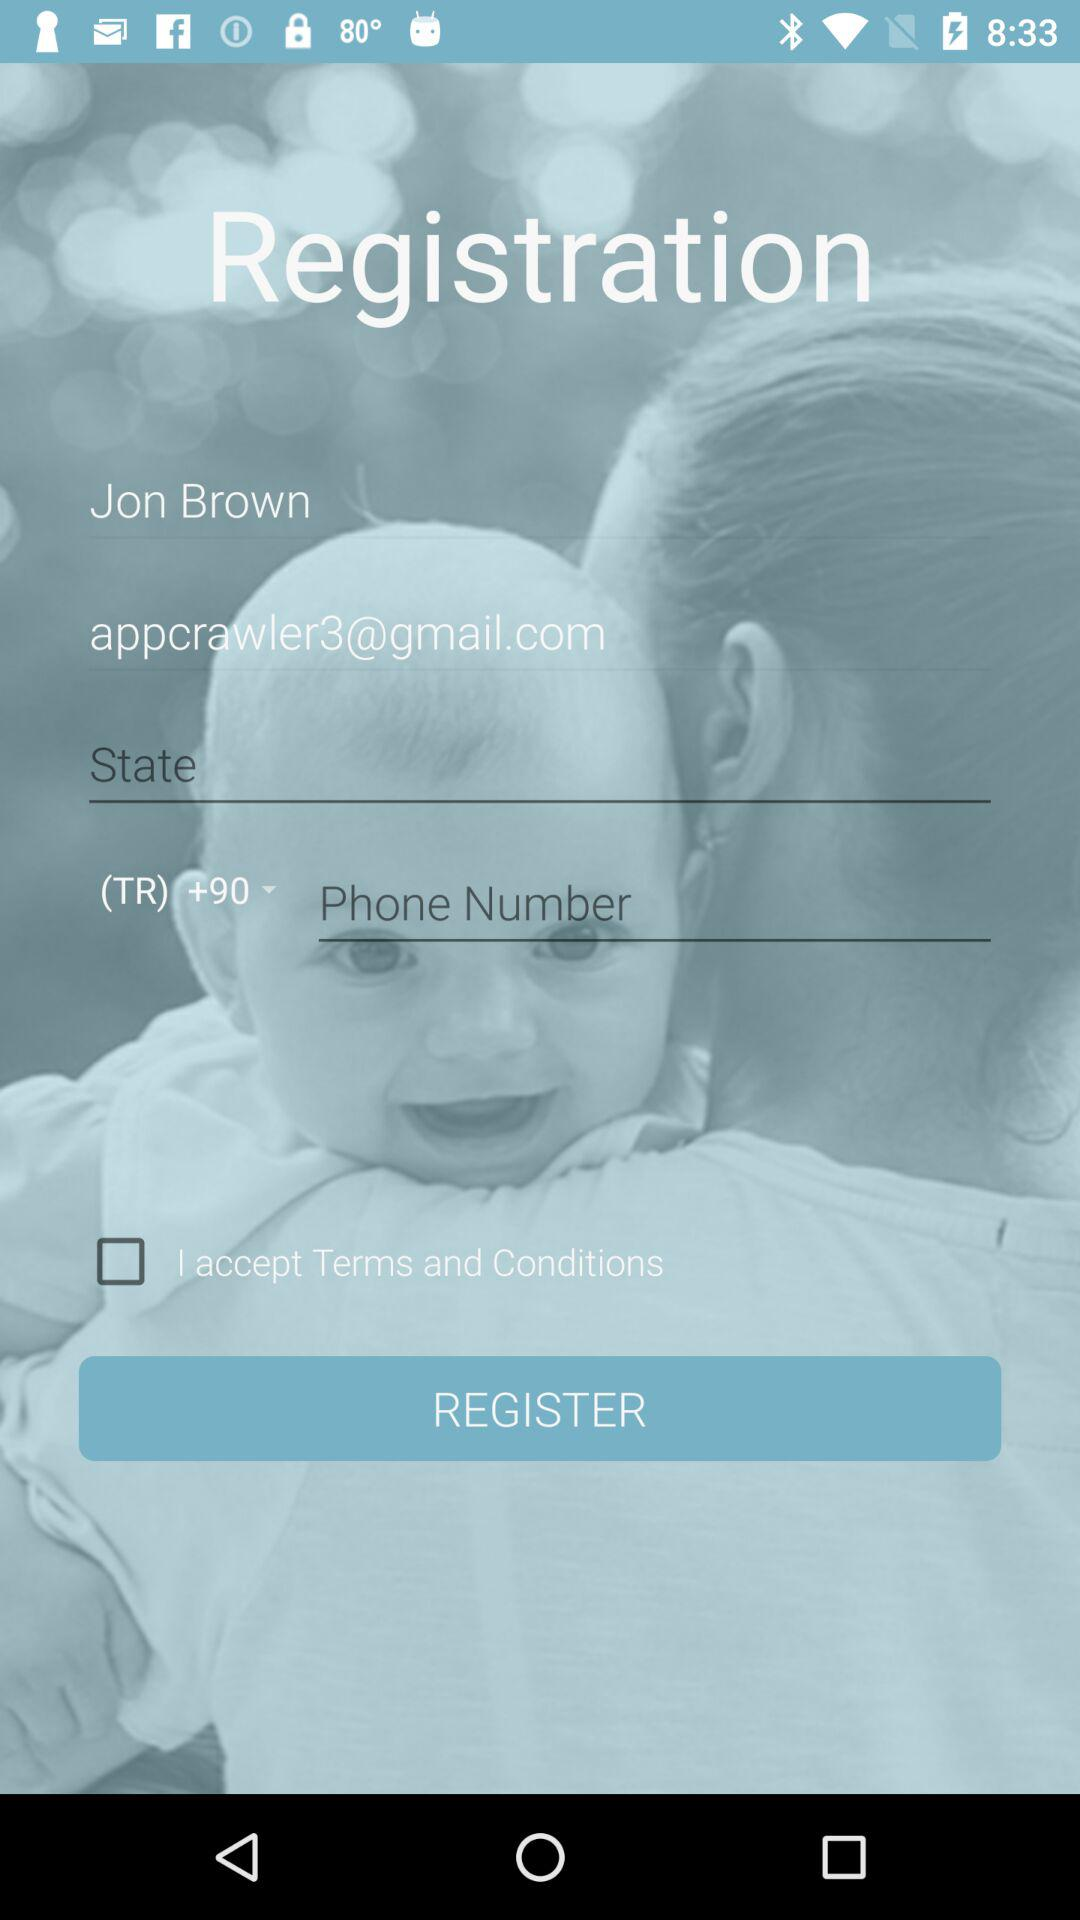What is the name of the user? The name of the user is Jon Brown. 